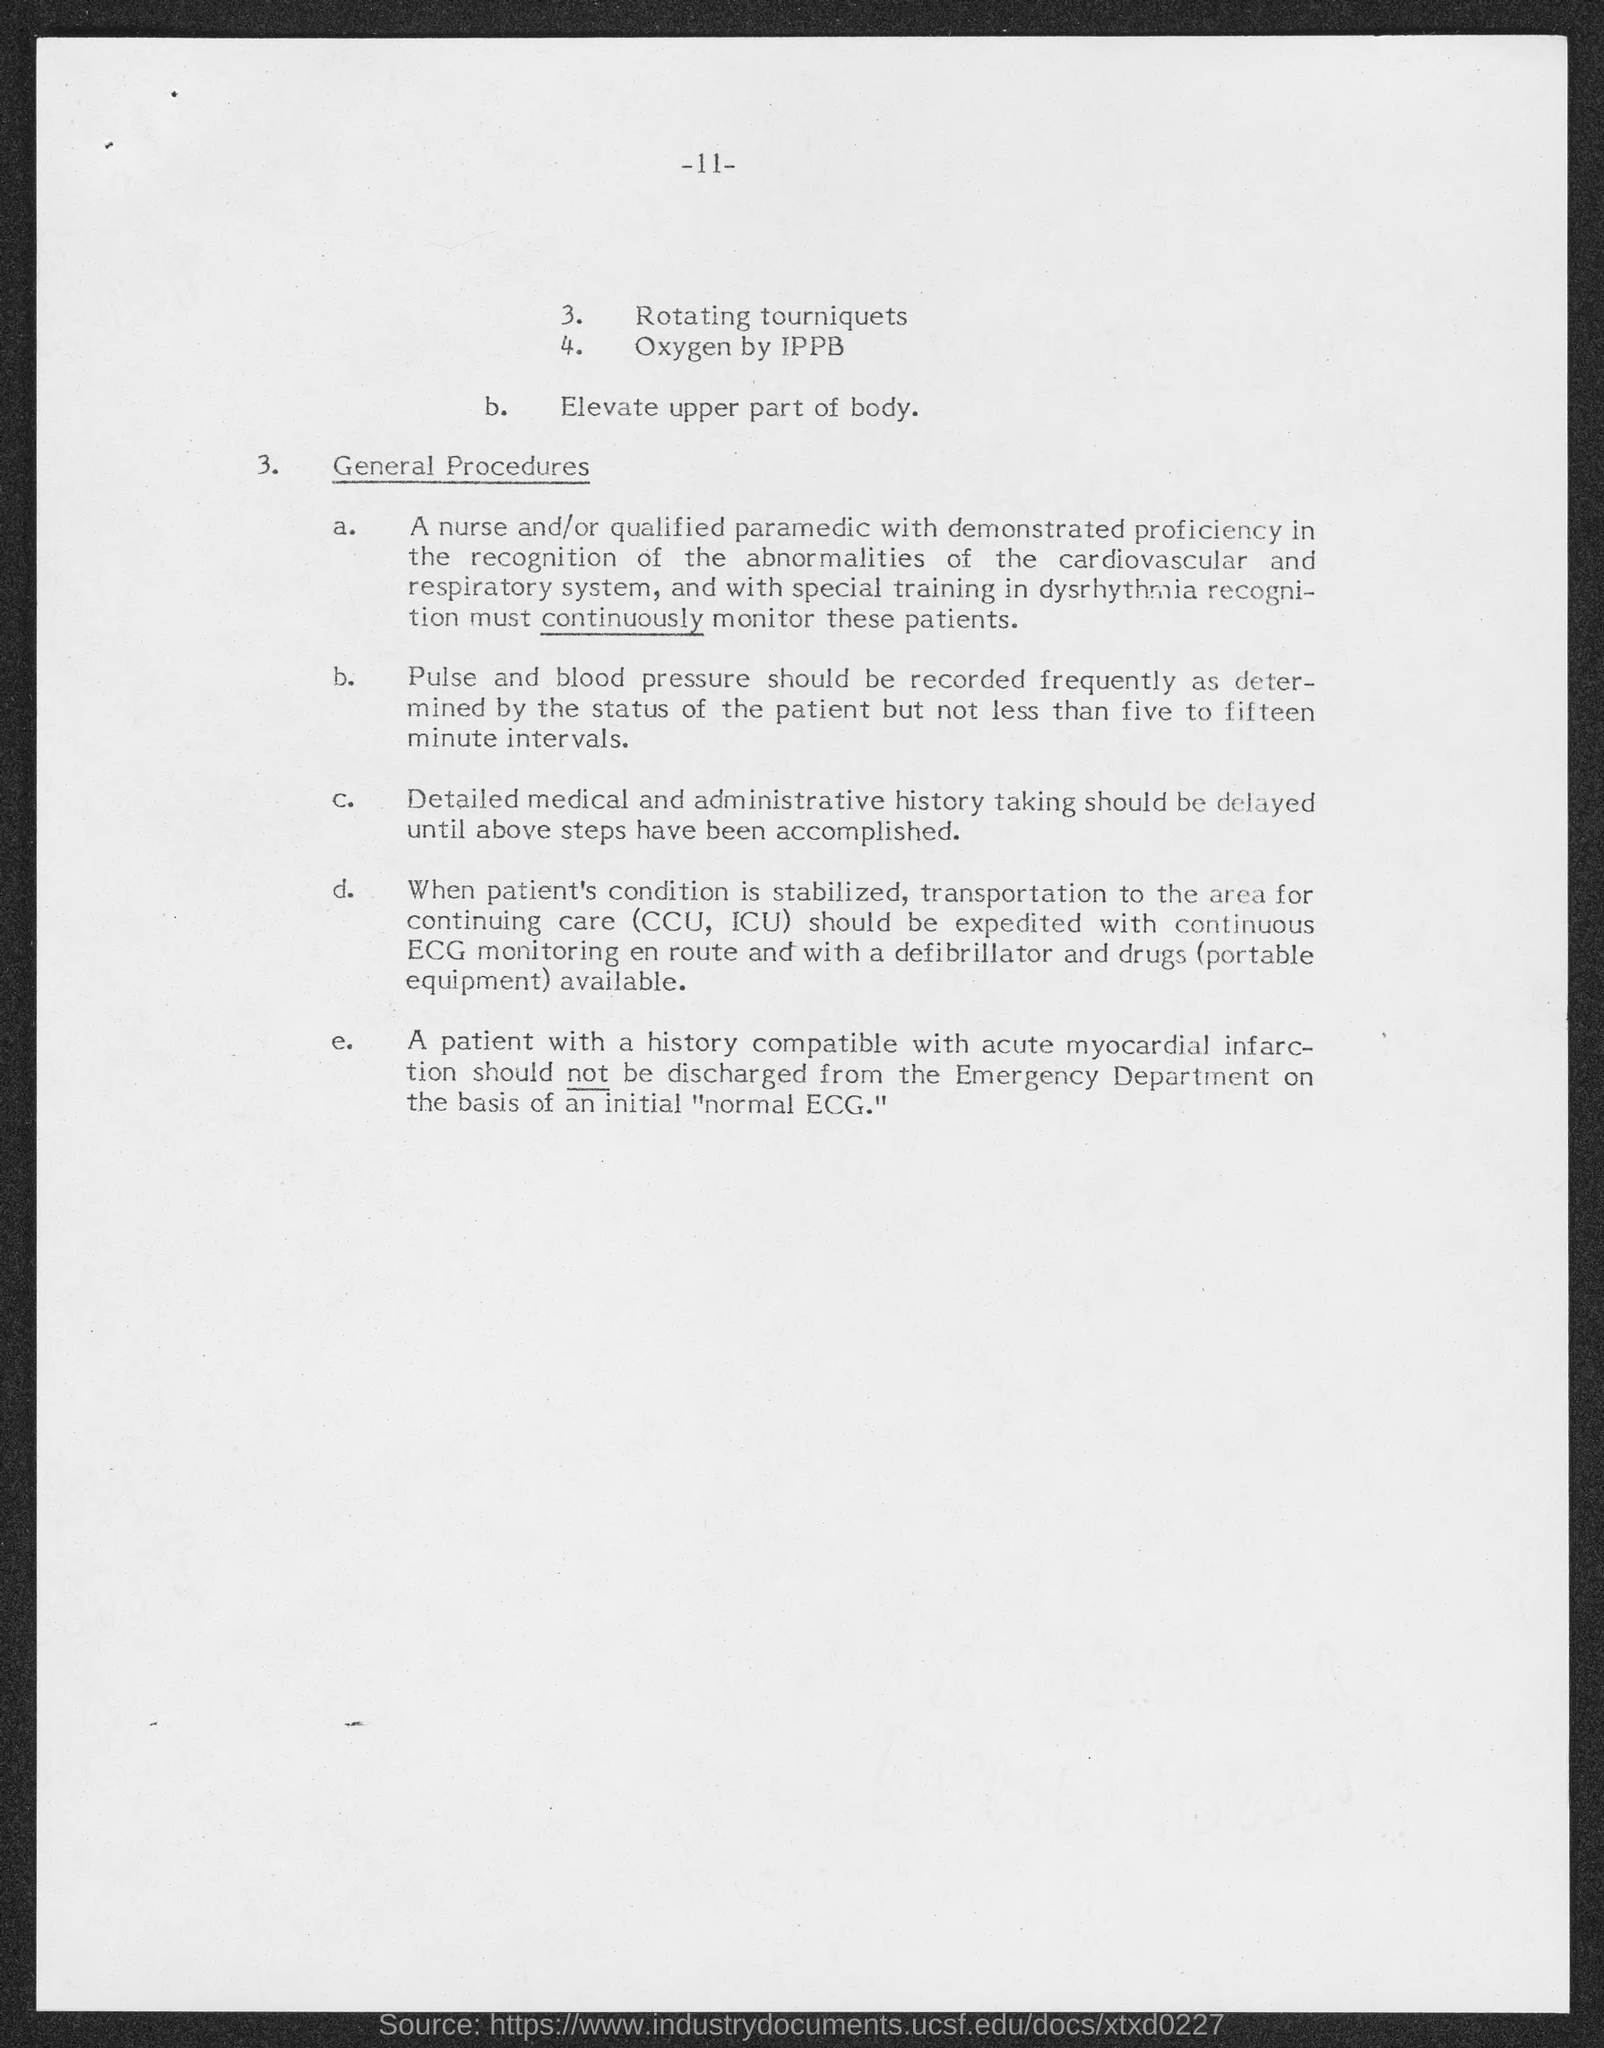What is the page number at top of the page?
Offer a terse response. -11-. 